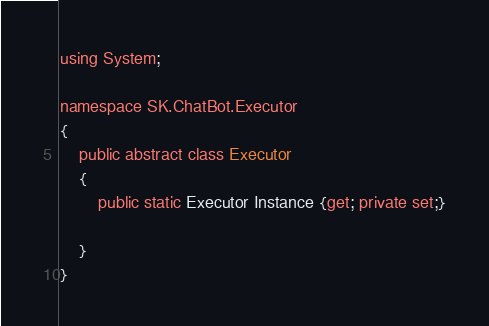Convert code to text. <code><loc_0><loc_0><loc_500><loc_500><_C#_>using System;

namespace SK.ChatBot.Executor
{
    public abstract class Executor
    {
        public static Executor Instance {get; private set;}

    }
}
</code> 